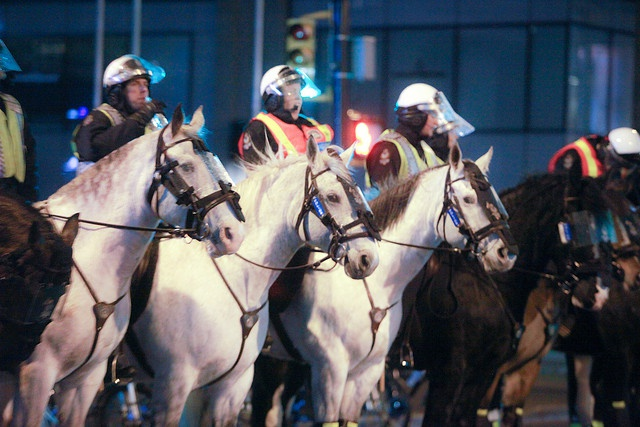Describe the objects in this image and their specific colors. I can see horse in black, beige, darkgray, and gray tones, horse in black, lightgray, darkgray, and gray tones, horse in black, maroon, gray, and navy tones, horse in black, beige, darkgray, and gray tones, and horse in black, maroon, and gray tones in this image. 